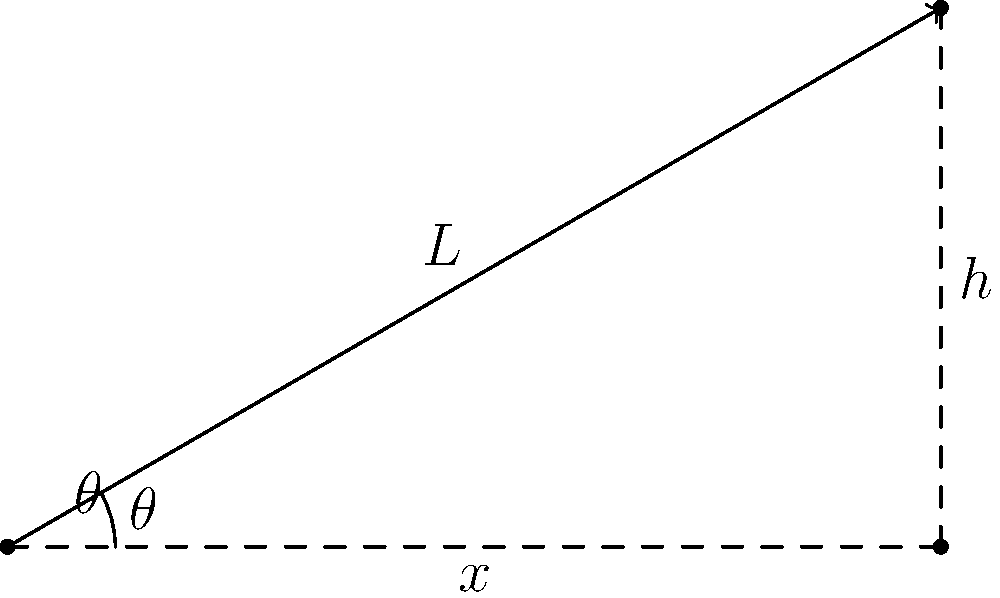As a veterinary student, you're designing a ramp to safely transport injured animals into an ambulance. The ramp needs to reach a height of 1.2 meters and can't exceed a length of 3 meters due to space constraints. What is the minimum angle $\theta$ (in degrees) the ramp should be inclined to meet these requirements? Let's approach this step-by-step:

1) We can use trigonometry to solve this problem. The ramp forms a right-angled triangle where:
   - The opposite side is the height (h) = 1.2 meters
   - The hypotenuse is the length of the ramp (L) ≤ 3 meters
   - The angle we're looking for is $\theta$

2) We know that in a right-angled triangle:

   $\sin(\theta) = \frac{\text{opposite}}{\text{hypotenuse}} = \frac{h}{L}$

3) We want the minimum angle, which will occur when the ramp is at its maximum length of 3 meters. So:

   $\sin(\theta) = \frac{1.2}{3} = 0.4$

4) To find $\theta$, we need to take the inverse sine (arcsin) of both sides:

   $\theta = \arcsin(0.4)$

5) Using a calculator or computer, we can compute this:

   $\theta \approx 23.5782$ degrees

6) Rounding up to ensure we meet the height requirement:

   $\theta \approx 23.6$ degrees

Therefore, the minimum angle the ramp should be inclined is approximately 23.6 degrees.
Answer: $23.6^\circ$ 